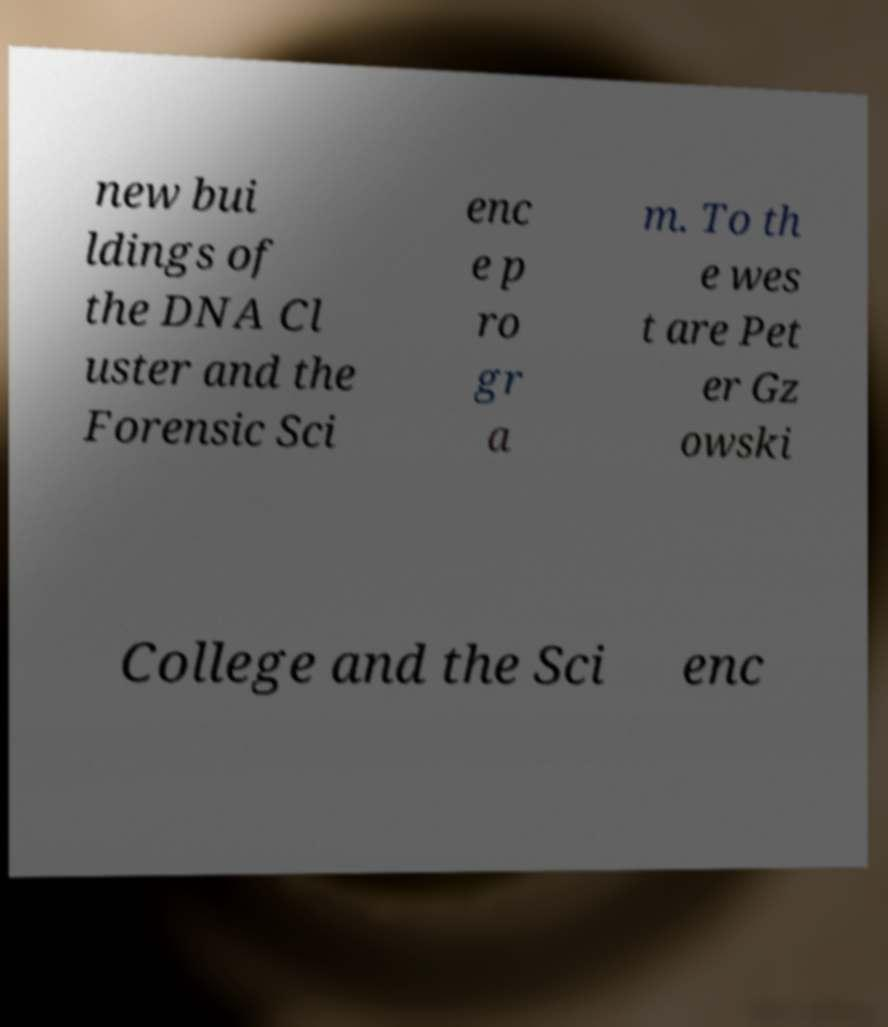Can you read and provide the text displayed in the image?This photo seems to have some interesting text. Can you extract and type it out for me? new bui ldings of the DNA Cl uster and the Forensic Sci enc e p ro gr a m. To th e wes t are Pet er Gz owski College and the Sci enc 